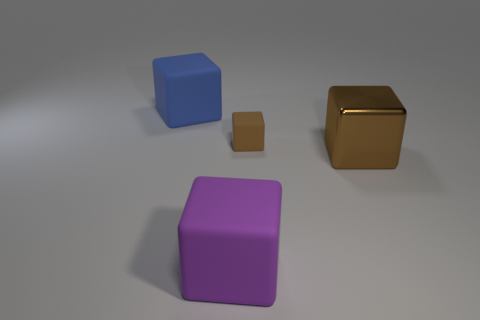Subtract 2 blocks. How many blocks are left? 2 Subtract all gray cubes. Subtract all yellow cylinders. How many cubes are left? 4 Add 1 big rubber cylinders. How many objects exist? 5 Subtract all big rubber blocks. Subtract all purple rubber blocks. How many objects are left? 1 Add 2 blue matte things. How many blue matte things are left? 3 Add 4 yellow things. How many yellow things exist? 4 Subtract 0 green spheres. How many objects are left? 4 